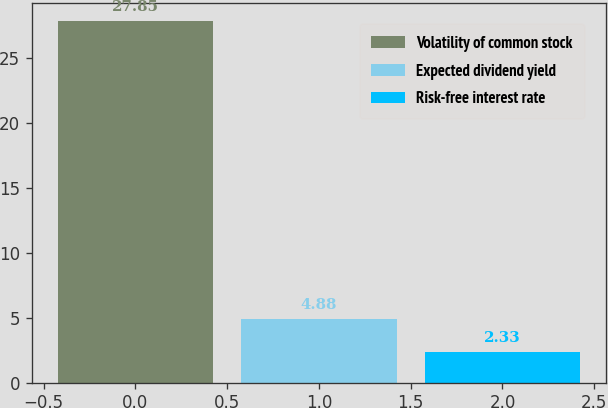Convert chart to OTSL. <chart><loc_0><loc_0><loc_500><loc_500><bar_chart><fcel>Volatility of common stock<fcel>Expected dividend yield<fcel>Risk-free interest rate<nl><fcel>27.85<fcel>4.88<fcel>2.33<nl></chart> 